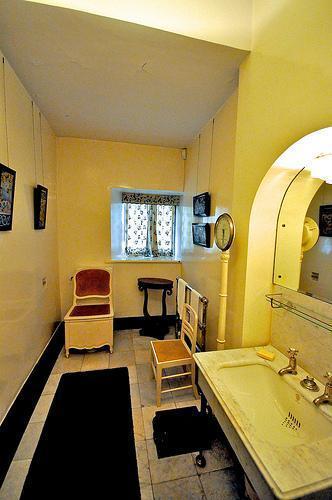How many chairs are there?
Give a very brief answer. 2. 